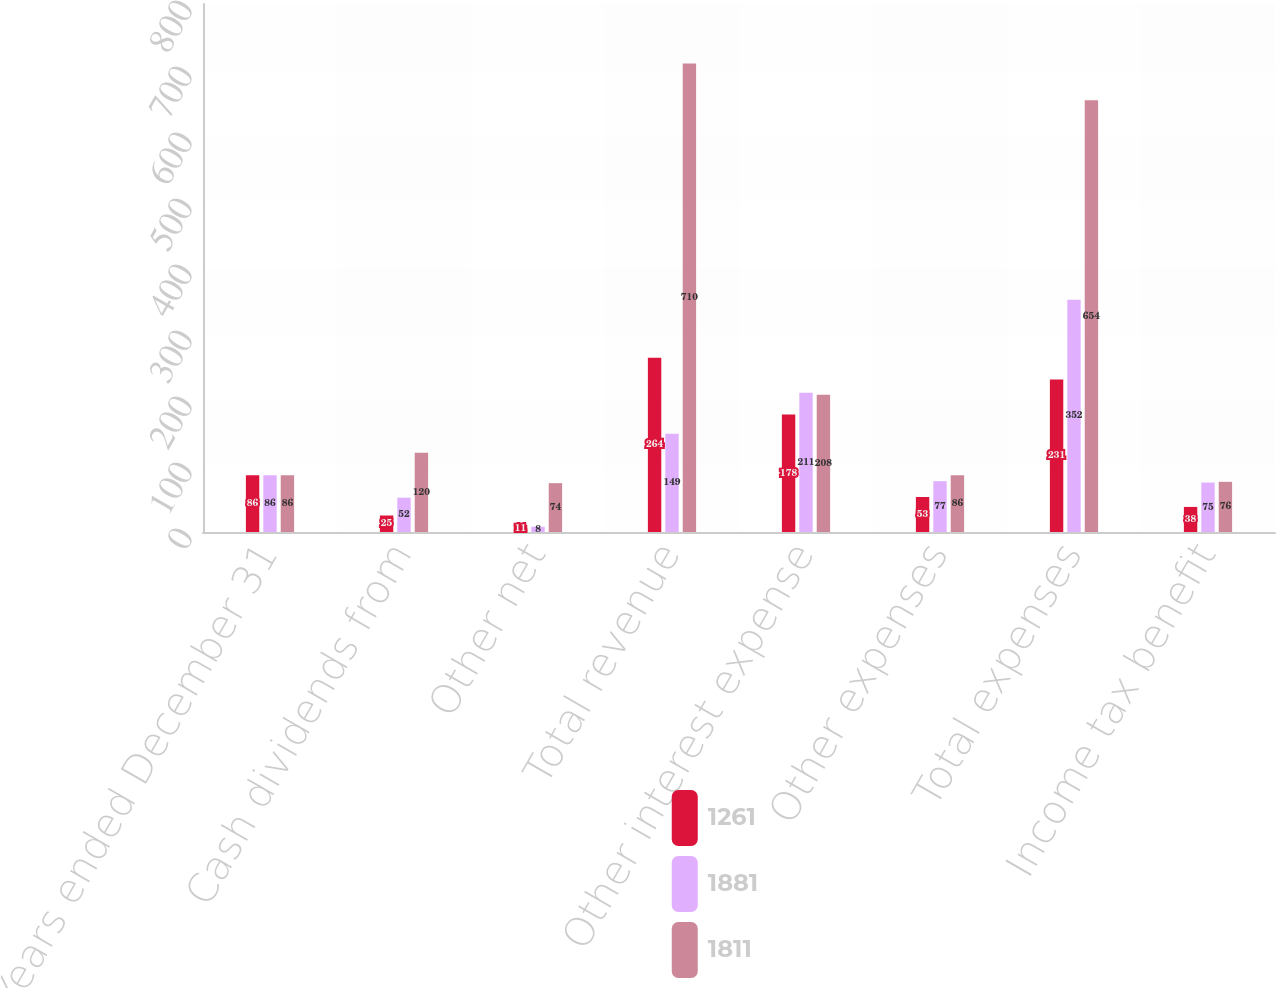<chart> <loc_0><loc_0><loc_500><loc_500><stacked_bar_chart><ecel><fcel>Years ended December 31<fcel>Cash dividends from<fcel>Other net<fcel>Total revenue<fcel>Other interest expense<fcel>Other expenses<fcel>Total expenses<fcel>Income tax benefit<nl><fcel>1261<fcel>86<fcel>25<fcel>11<fcel>264<fcel>178<fcel>53<fcel>231<fcel>38<nl><fcel>1881<fcel>86<fcel>52<fcel>8<fcel>149<fcel>211<fcel>77<fcel>352<fcel>75<nl><fcel>1811<fcel>86<fcel>120<fcel>74<fcel>710<fcel>208<fcel>86<fcel>654<fcel>76<nl></chart> 